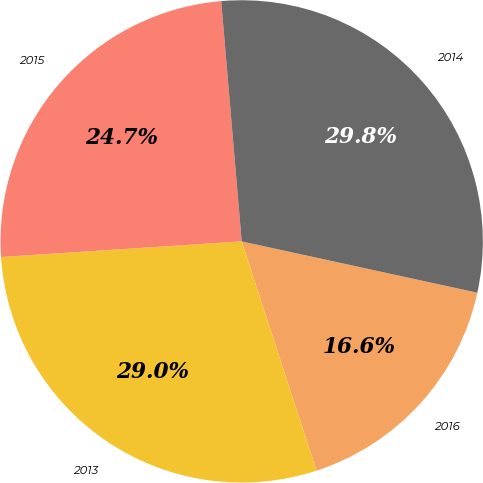Convert chart to OTSL. <chart><loc_0><loc_0><loc_500><loc_500><pie_chart><fcel>2016<fcel>2013<fcel>2015<fcel>2014<nl><fcel>16.57%<fcel>28.99%<fcel>24.68%<fcel>29.77%<nl></chart> 